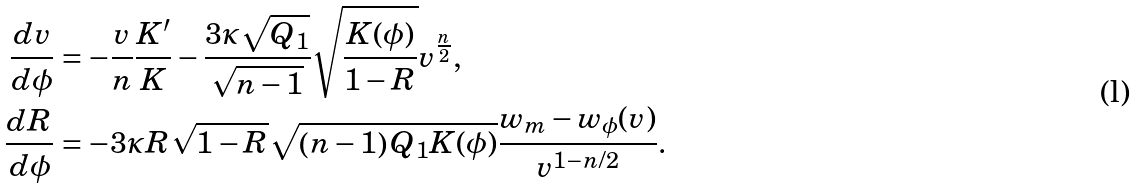<formula> <loc_0><loc_0><loc_500><loc_500>\frac { d v } { d \phi } & = - \frac { v } { n } \frac { K ^ { \prime } } { K } - \frac { 3 \kappa \sqrt { Q _ { 1 } } } { \sqrt { n - 1 } } \sqrt { \frac { K ( \phi ) } { 1 - R } } v ^ { \frac { n } { 2 } } , \\ \frac { d R } { d \phi } & = - 3 \kappa R \sqrt { 1 - R } \sqrt { \left ( n - 1 \right ) Q _ { 1 } K ( \phi ) } \frac { w _ { m } - w _ { \phi } ( v ) } { v ^ { 1 - n / 2 } } .</formula> 